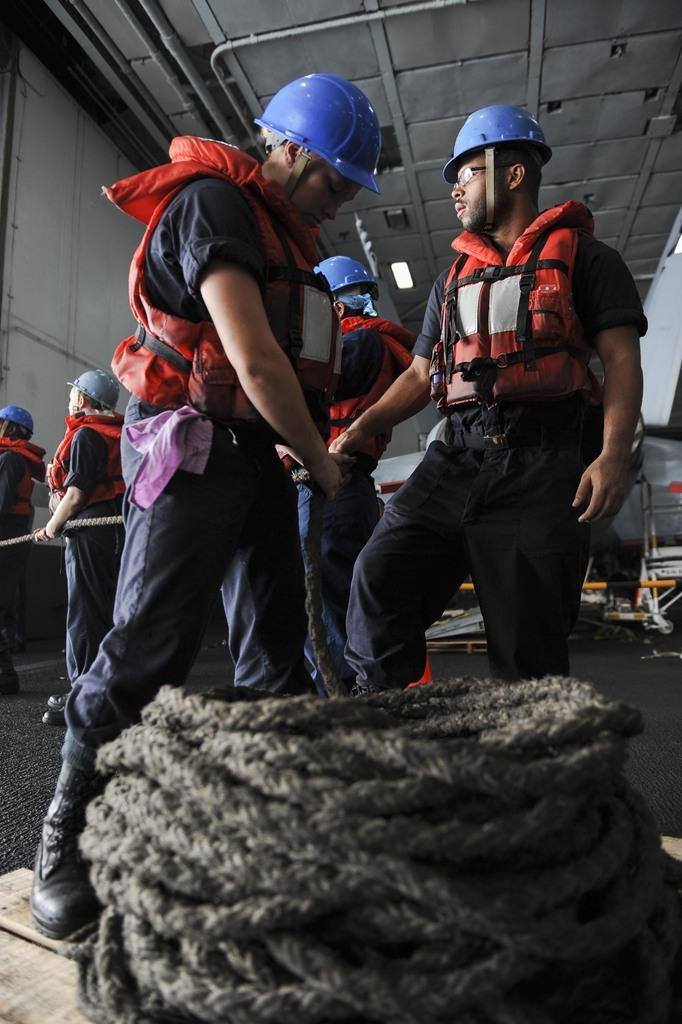What can be seen in the image involving a group of people? There is a group of men in the image. What are the men holding in the image? The men are holding a rope. What type of protective gear are the men wearing in the image? The men are wearing red life jackets and blue helmets. What color are the trousers worn by the men in the image? The men are wearing grey trousers. Can you describe the rope visible in the image? The rope is visible in the image. What type of flesh can be seen on the cart in the image? There is no cart or flesh present in the image. How many hairs are visible on the men's heads in the image? The image does not provide enough detail to count individual hairs on the men's heads. 